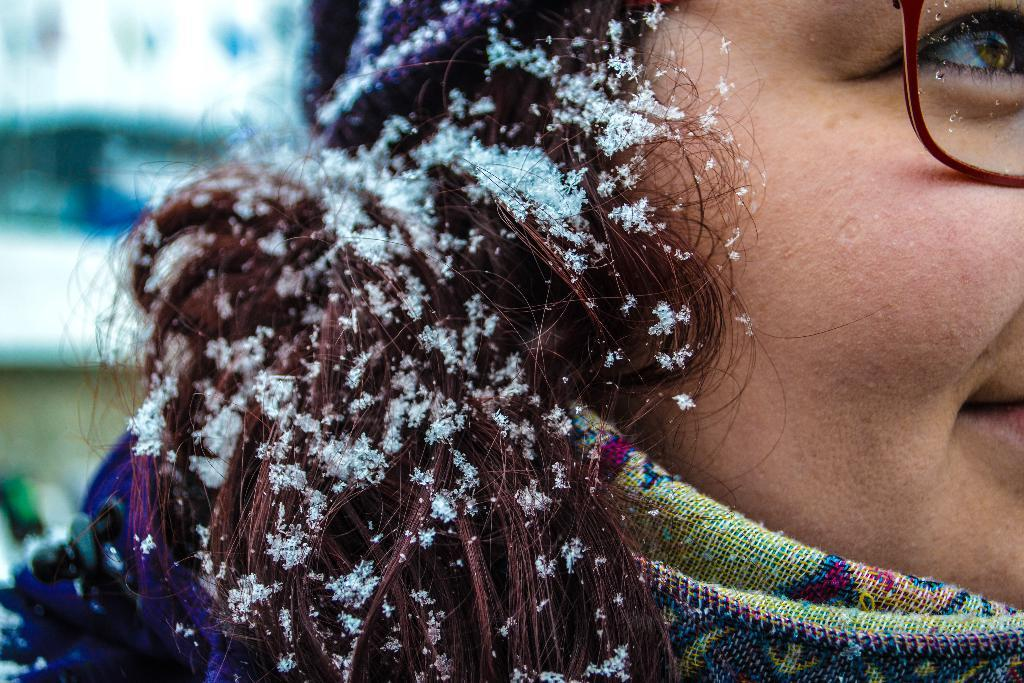Who is present in the image? There is a woman in the image. What accessory is the woman wearing? The woman is wearing glasses (specs). What is the weather condition in the image? There is snow on the woman's hair, indicating a cold or snowy environment. How would you describe the background of the image? The background of the image is blurry. What type of operation is the woman performing in the image? There is no indication of an operation or any medical procedure in the image. The woman is simply standing with snow on her hair and wearing glasses. 